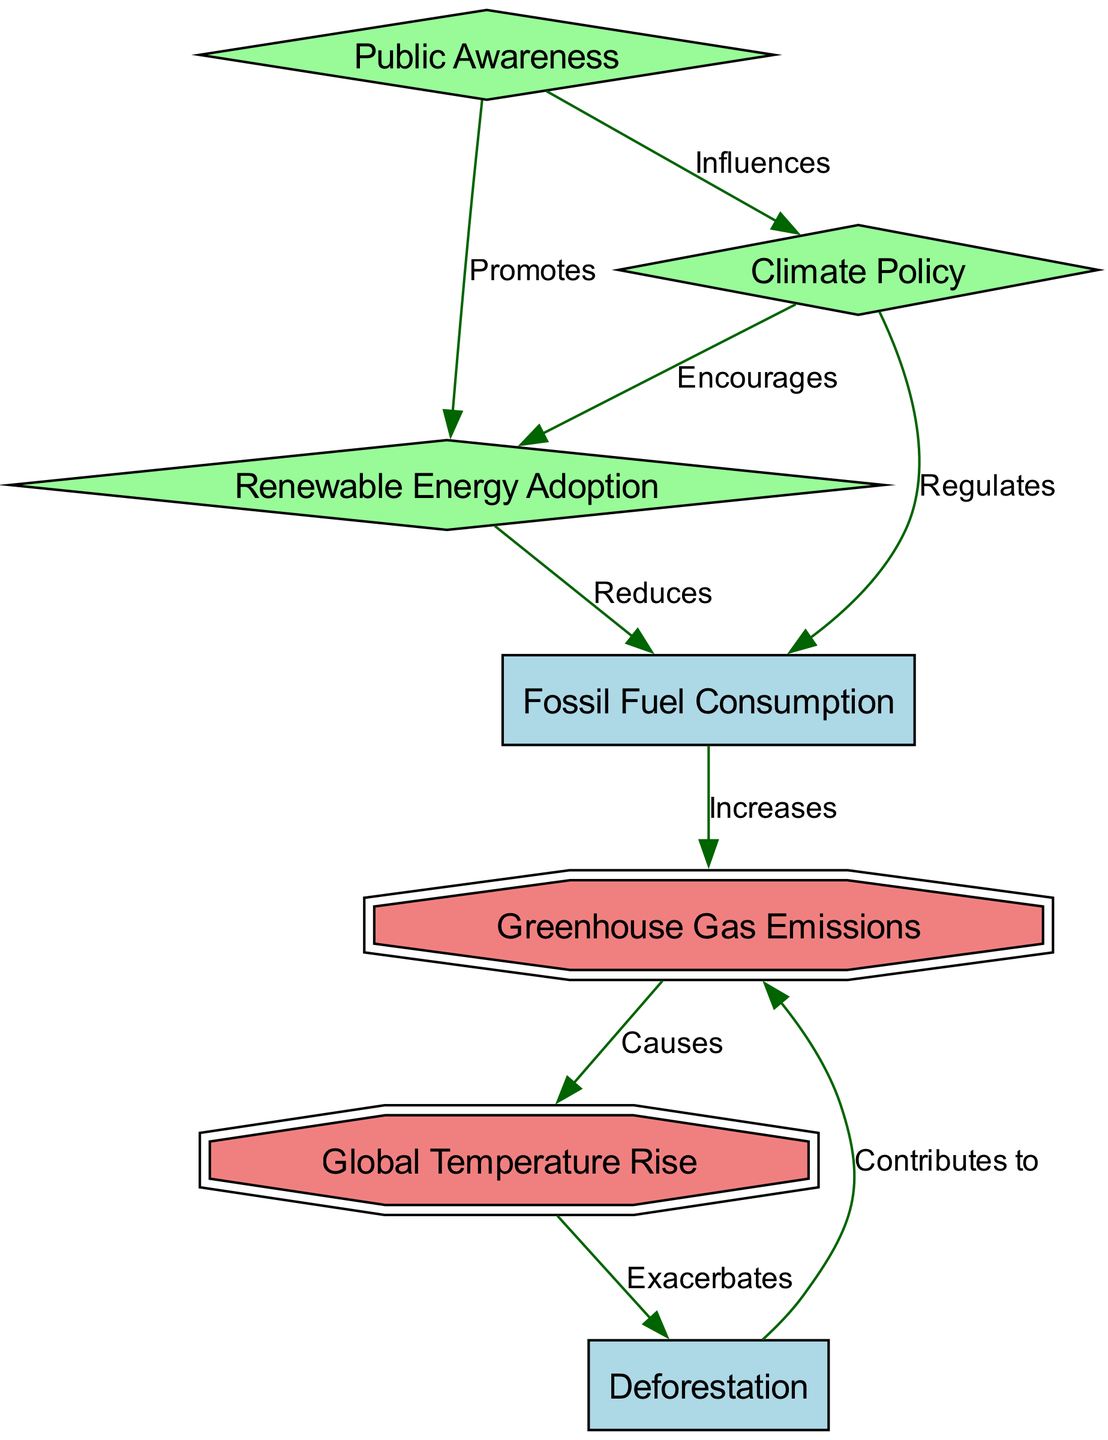What are the main factors contributing to greenhouse gas emissions? The diagram lists fossil fuel consumption and deforestation as key contributors, indicated by direct connections to the greenhouse gas emissions node.
Answer: Fossil fuel consumption, deforestation How many nodes are there in the diagram? Counting the listed factors and influences in the diagram results in a total of seven nodes.
Answer: Seven What is the nature of the relationship between global temperature rise and deforestation? The diagram shows that global temperature rise exacerbates deforestation, creating a feedback loop that indicates that as temperatures rise, it leads to increased deforestation.
Answer: Exacerbates Which node promotes renewable energy adoption? Public awareness is indicated as the factor promoting renewable energy adoption, as shown by the directed edge from public awareness to renewable energy adoption in the diagram.
Answer: Public awareness What regulates fossil fuel consumption? Climate policy is depicted as regulating fossil fuel consumption, based on the directed edge that connects the climate policy node to the fossil fuel consumption node.
Answer: Climate policy How does public awareness influence climate policy? The diagram shows that public awareness influences climate policy positively, as indicated by the directed connection from public awareness to climate policy.
Answer: Influences What type of node represents renewable energy adoption? The diagram specifies renewable energy adoption as a diamond-shaped node, which differentiates it from other types such as greenhouse gas emissions and global temperature rise, which are double octagons.
Answer: Diamond What type of relationships exist between greenhouse gas emissions and global temperature rise? The diagram explicitly states a causal relationship where greenhouse gas emissions cause global temperature rise, shown by a directed edge between these two nodes.
Answer: Causes What action is influenced by climate policy according to the diagram? The diagram indicates that climate policy encourages renewable energy adoption, as shown by the directional influence from the climate policy node to renewable energy adoption.
Answer: Encourages 